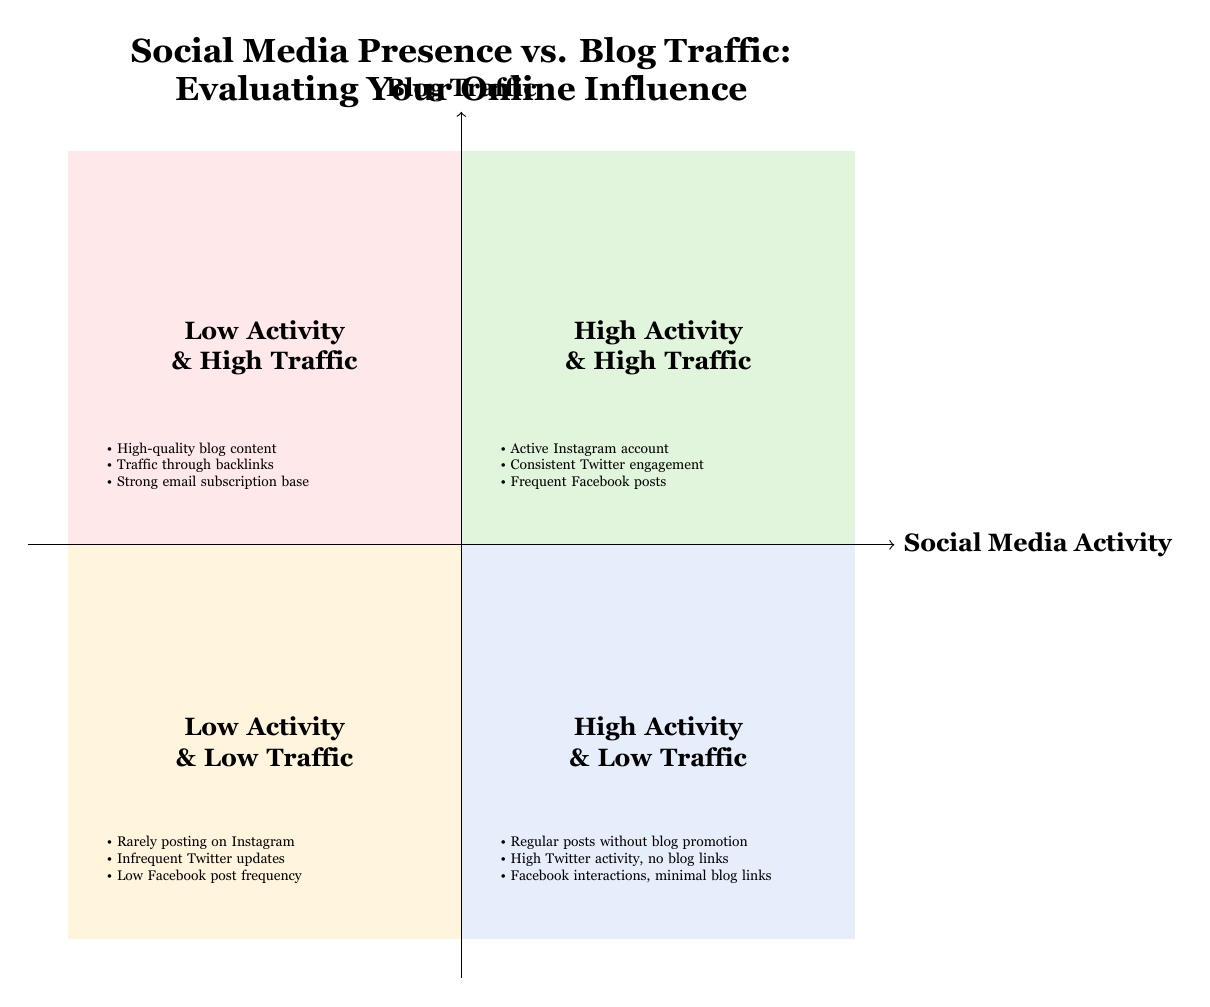What is the title of the chart? The title clearly stated at the top of the diagram is "Social Media Presence vs. Blog Traffic: Evaluating Your Online Influence." This can be found prominently positioned above the quadrants.
Answer: Social Media Presence vs. Blog Traffic: Evaluating Your Online Influence Which quadrant corresponds to high social media activity and low blog traffic? By examining the labels within the quadrants, we see that the one in the bottom right section of the diagram is named "High Activity & Low Traffic." This directly addresses the question regarding the positioning within the quadrant chart.
Answer: High Activity & Low Traffic What are two examples from the "Low Activity & Low Traffic" quadrant? The description provided within the diagram for the "Low Activity & Low Traffic" quadrant includes several examples. Picking any two from this section, such as "Rarely posting on Instagram" and "Low Facebook post frequency," gives the answer.
Answer: Rarely posting on Instagram, Low Facebook post frequency How many quadrants are shown in the diagram? The diagram is structured into four distinct sections, known as quadrants, representing different combinations of social media activity and blog traffic. Thus, the count of quadrants in this chart is four.
Answer: Four What can be inferred if a blog has high activity but low traffic? From the description of the "High Activity & Low Traffic" quadrant, it can be inferred that such a situation indicates there may be a content disconnect or ineffective calls-to-action to drive traffic to the blog. This interpretation requires reasoning about the relationship between social media engagement and blog visitations.
Answer: Content disconnect or need for better calls-to-action What does the "Low Activity & High Traffic" quadrant suggest about blog traffic sources? The description in the "Low Activity & High Traffic" quadrant suggests that despite minimal social media engagement, it indicates that blog traffic could be coming from strong SEO or word-of-mouth referrals, highlighting the importance of quality blog content and external backlinks.
Answer: Strong SEO or word-of-mouth traffic Which quadrant would an active TikTok account likely fall into if it's not driving blog traffic? Given that an active TikTok account signifies high engagement on a social media platform, and if it does not lead to increased blog traffic, it would likely be categorized in the "High Activity & Low Traffic" quadrant, based on the information about their relationship.
Answer: High Activity & Low Traffic What is the most significant issue indicated by the "High Activity & Low Traffic" quadrant? This quadrant signifies that, despite maintaining a high level of social media activity, the primary concern suggested here is the need for improved strategies to direct visitors to the blog effectively, indicating a potential lack of blog promotion.
Answer: Need for blog promotion 